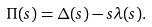<formula> <loc_0><loc_0><loc_500><loc_500>\Pi ( s ) = \Delta ( s ) - s \lambda ( s ) .</formula> 